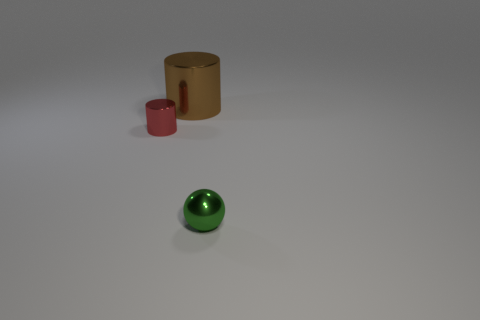Is there a purple shiny ball?
Give a very brief answer. No. What is the color of the tiny metal object to the left of the metallic object in front of the red metallic object?
Your answer should be very brief. Red. There is a tiny thing that is the same shape as the big shiny thing; what material is it?
Give a very brief answer. Metal. How many brown cylinders have the same size as the red thing?
Ensure brevity in your answer.  0. There is a red cylinder that is made of the same material as the green object; what is its size?
Offer a terse response. Small. How many brown things are the same shape as the red object?
Give a very brief answer. 1. What number of metal cylinders are there?
Your response must be concise. 2. There is a small metallic object to the left of the big brown thing; is its shape the same as the big brown shiny thing?
Keep it short and to the point. Yes. Are there any blue objects made of the same material as the tiny green object?
Your response must be concise. No. There is a brown thing; is its shape the same as the metal thing that is to the left of the large metallic cylinder?
Keep it short and to the point. Yes. 